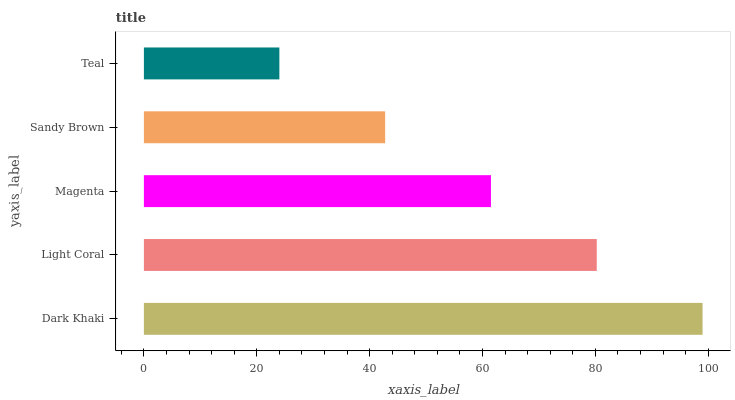Is Teal the minimum?
Answer yes or no. Yes. Is Dark Khaki the maximum?
Answer yes or no. Yes. Is Light Coral the minimum?
Answer yes or no. No. Is Light Coral the maximum?
Answer yes or no. No. Is Dark Khaki greater than Light Coral?
Answer yes or no. Yes. Is Light Coral less than Dark Khaki?
Answer yes or no. Yes. Is Light Coral greater than Dark Khaki?
Answer yes or no. No. Is Dark Khaki less than Light Coral?
Answer yes or no. No. Is Magenta the high median?
Answer yes or no. Yes. Is Magenta the low median?
Answer yes or no. Yes. Is Sandy Brown the high median?
Answer yes or no. No. Is Light Coral the low median?
Answer yes or no. No. 